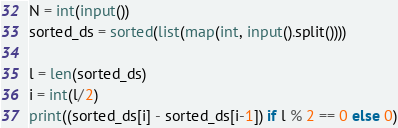Convert code to text. <code><loc_0><loc_0><loc_500><loc_500><_Python_>N = int(input())
sorted_ds = sorted(list(map(int, input().split())))

l = len(sorted_ds)
i = int(l/2)
print((sorted_ds[i] - sorted_ds[i-1]) if l % 2 == 0 else 0)
</code> 